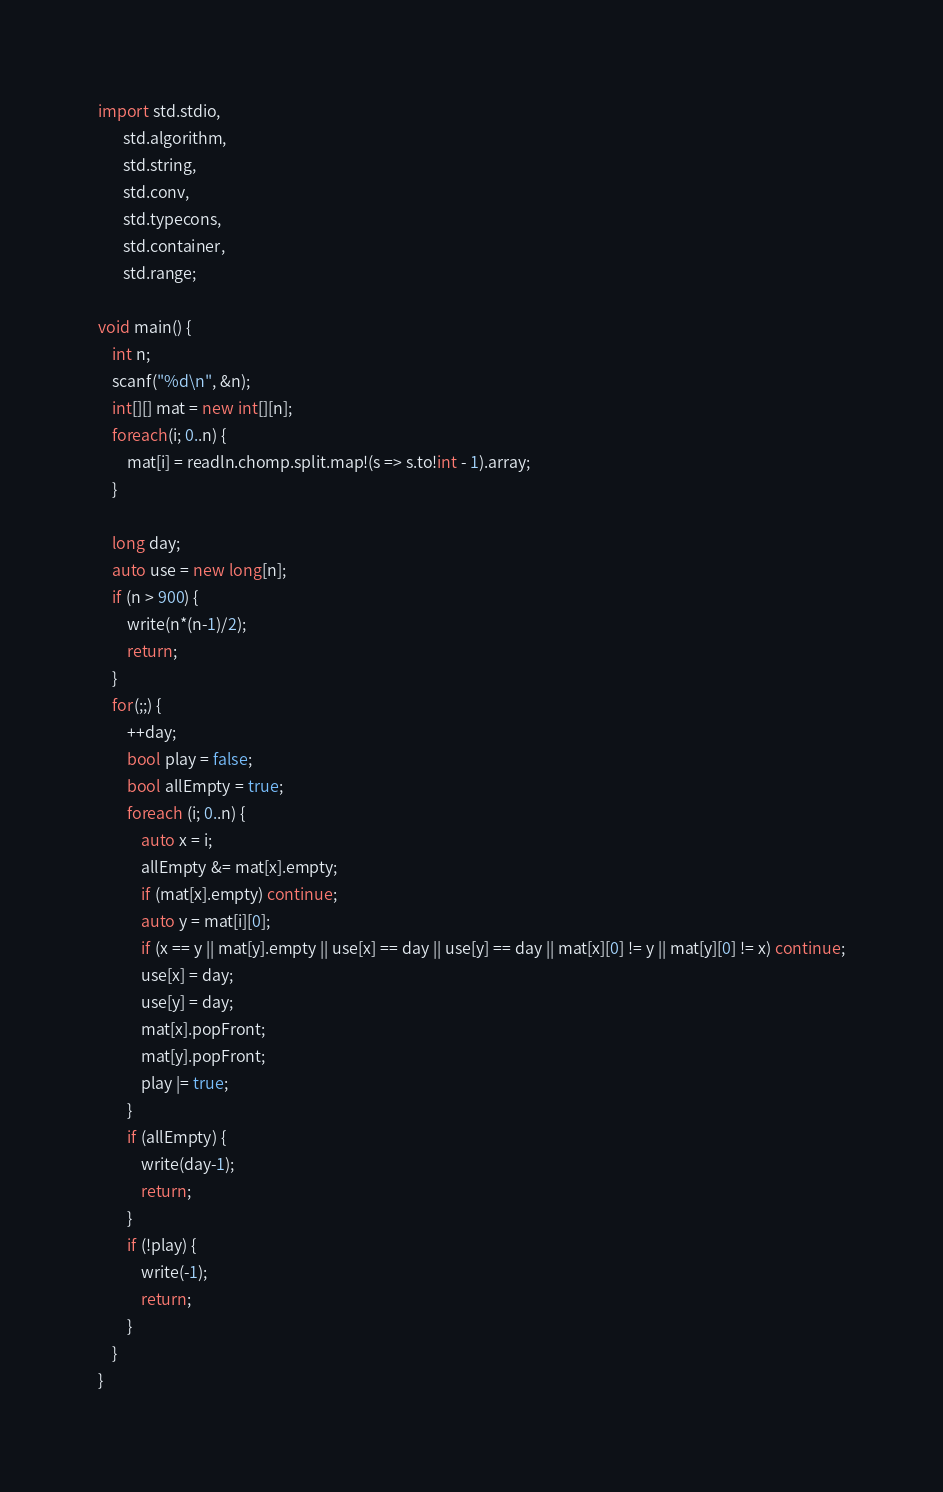<code> <loc_0><loc_0><loc_500><loc_500><_D_>import std.stdio,
	   std.algorithm,
	   std.string,
	   std.conv,
	   std.typecons,
	   std.container,
	   std.range;

void main() {
	int n;
	scanf("%d\n", &n);
	int[][] mat = new int[][n];
	foreach(i; 0..n) {
		mat[i] = readln.chomp.split.map!(s => s.to!int - 1).array;
	}

	long day;
	auto use = new long[n];
	if (n > 900) {
		write(n*(n-1)/2);
		return;
	}
	for(;;) {
		++day;
		bool play = false;
		bool allEmpty = true;
		foreach (i; 0..n) {
			auto x = i;
			allEmpty &= mat[x].empty;
			if (mat[x].empty) continue;
			auto y = mat[i][0];
			if (x == y || mat[y].empty || use[x] == day || use[y] == day || mat[x][0] != y || mat[y][0] != x) continue;
			use[x] = day;
			use[y] = day;
			mat[x].popFront;
			mat[y].popFront;
			play |= true;
		}
		if (allEmpty) {
			write(day-1);
			return;
		}
		if (!play) {
			write(-1);
			return;
		}
	}
}
</code> 